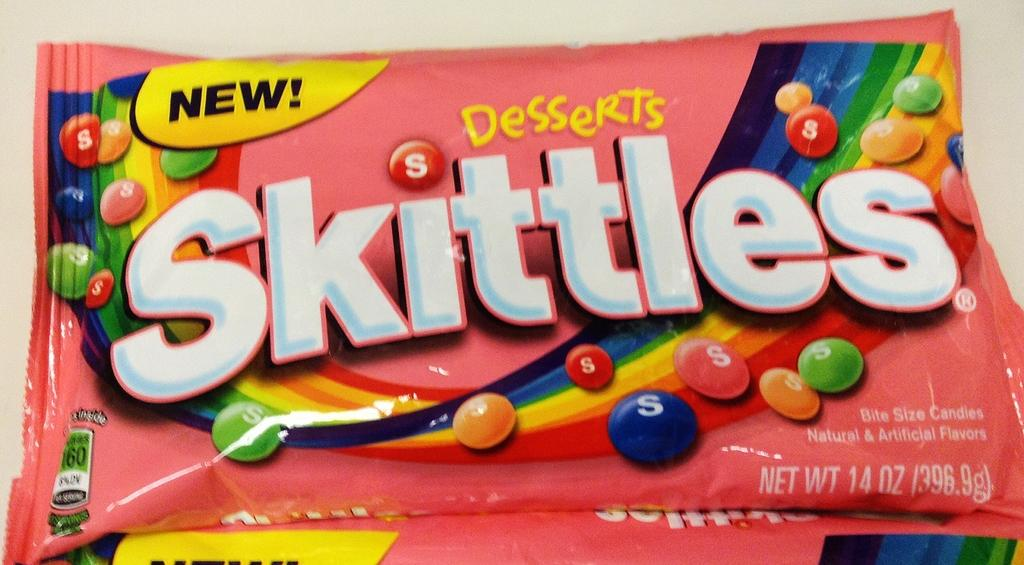What is the main object in the image? There is a food packet in the image. What information is present on the food packet? There are numbers and text on the food packet. How much pain is the food packet experiencing in the image? The food packet is an inanimate object and does not experience pain. 